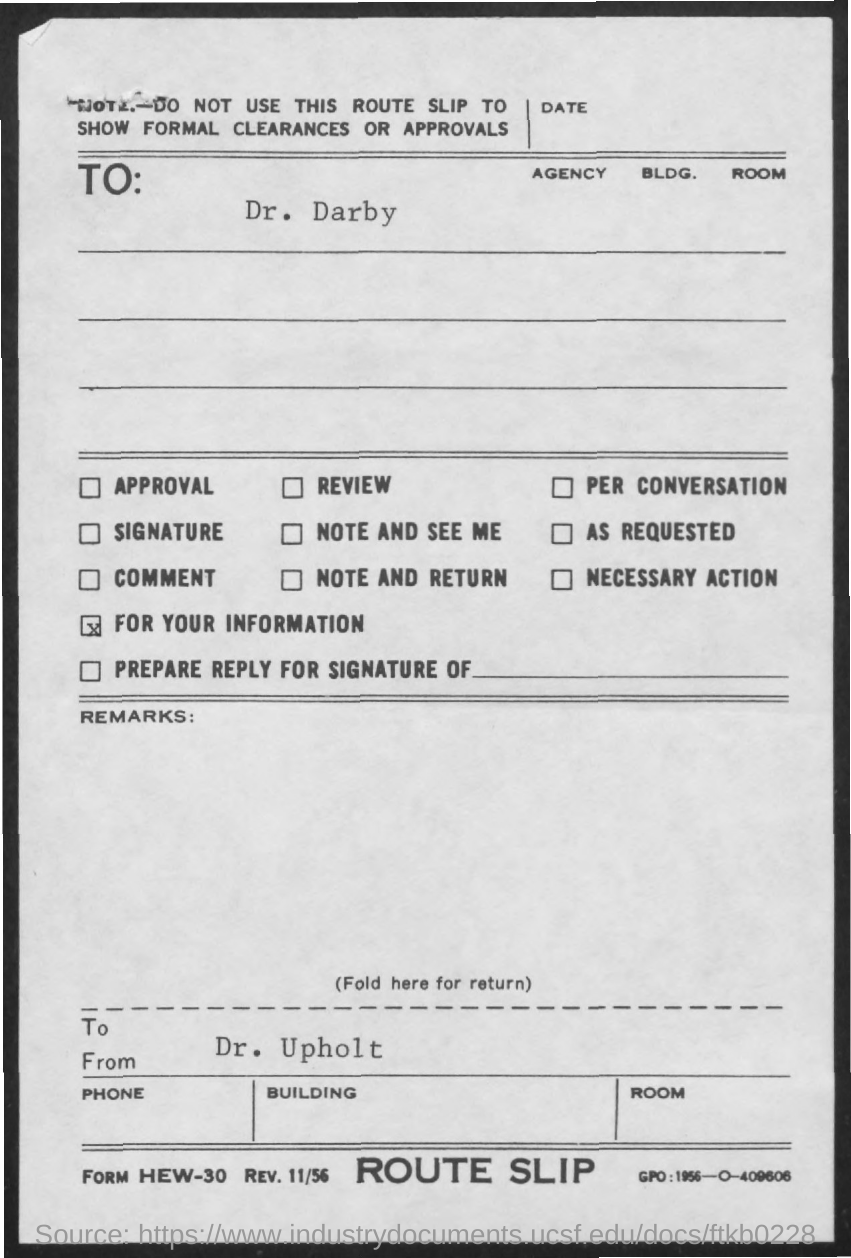To Whom is this letter addressed to?
Provide a succinct answer. DR. DARBY. Who is this letter from?
Ensure brevity in your answer.  DR. UPHOLT. 